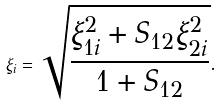<formula> <loc_0><loc_0><loc_500><loc_500>\xi _ { i } = \sqrt { \frac { \xi _ { 1 i } ^ { 2 } + S _ { 1 2 } \xi _ { 2 i } ^ { 2 } } { 1 + S _ { 1 2 } } } .</formula> 